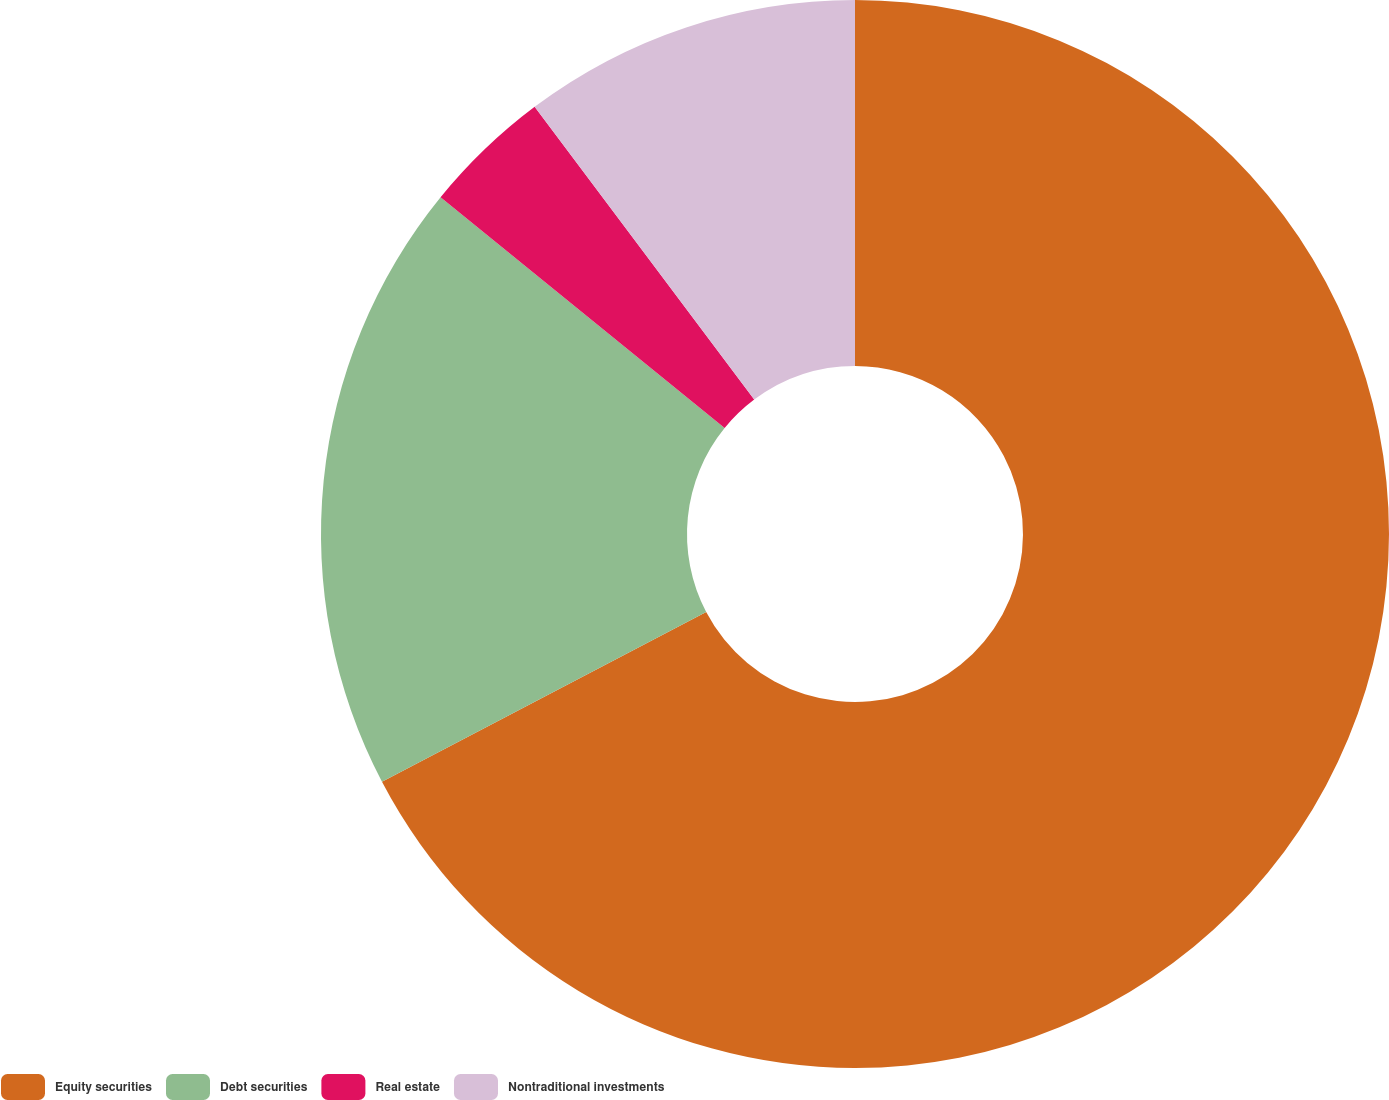<chart> <loc_0><loc_0><loc_500><loc_500><pie_chart><fcel>Equity securities<fcel>Debt securities<fcel>Real estate<fcel>Nontraditional investments<nl><fcel>67.32%<fcel>18.54%<fcel>3.9%<fcel>10.24%<nl></chart> 